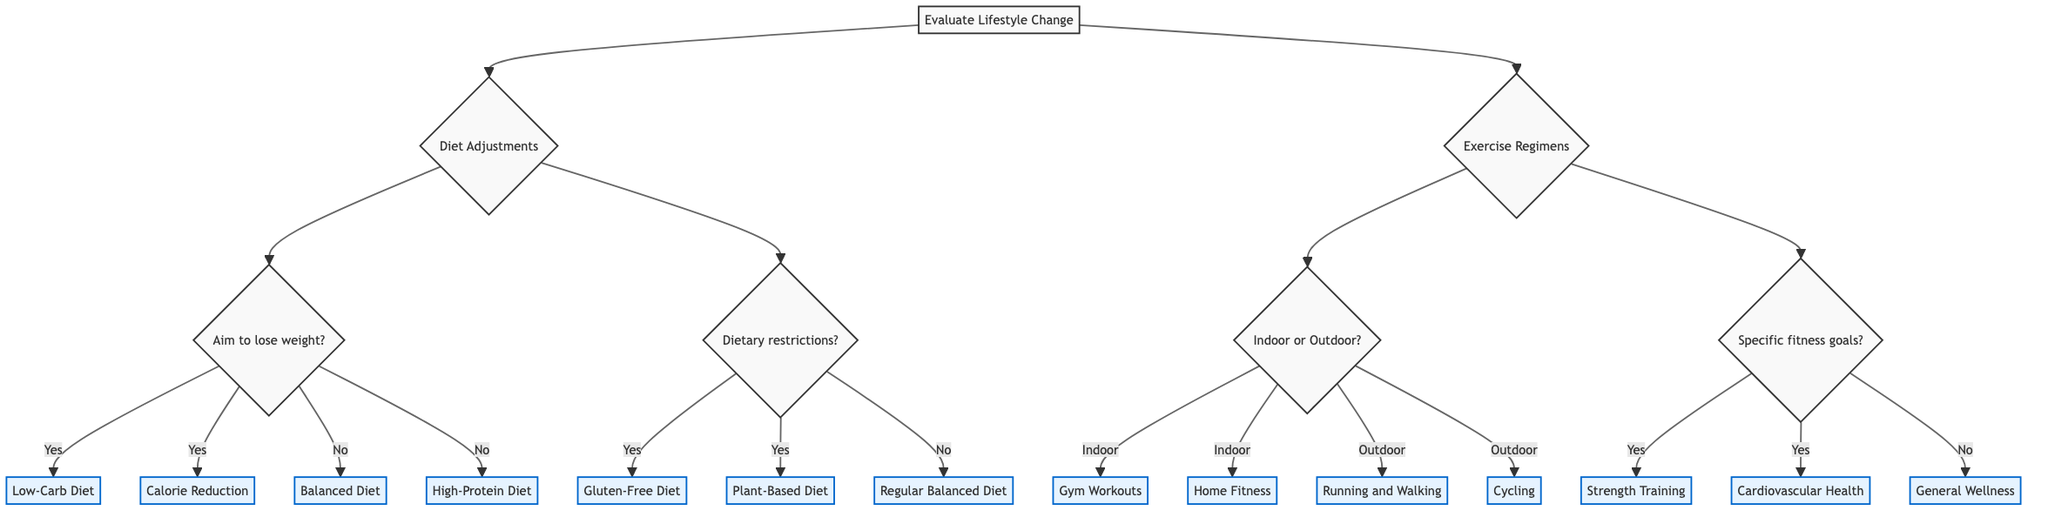What are the two main categories of lifestyle changes considered in this diagram? The diagram starts from a central point labeled "Evaluate Lifestyle Change" and branches into two main options: "Diet Adjustments" and "Exercise Regimens."
Answer: Diet Adjustments, Exercise Regimens How many options are there under "Diet Adjustments"? Under the "Diet Adjustments" branch, there are a total of four options following the questions regarding weight loss and dietary restrictions. These options include Low-Carb Diet, Calorie Reduction, Balanced Diet, and High-Protein Diet.
Answer: Four If someone wants to lose weight, what are the two diet options available to them? For someone aiming to lose weight, the diagram presents two options after they answer "yes" to the question about weight loss. These options are Low-Carb Diet and Calorie Reduction.
Answer: Low-Carb Diet, Calorie Reduction What type of exercise options can one pursue if they prefer outdoor activities? The diagram indicates that if a person selects "Outdoor" after the question about activity preference, they will be given two options: Running and Walking, and Cycling.
Answer: Running and Walking, Cycling What exercise regimen is suggested if the individual has specific fitness goals? If the individual targets specific fitness goals, the diagram shows that they can choose between Strength Training or Cardiovascular Health. These are found in the exercise assessment section focused on fitness goals.
Answer: Strength Training, Cardiovascular Health What detail is provided for those considering a Plant-Based Diet? The diagram includes a specific detail for the Plant-Based Diet option within the dietary adjustments criteria. It suggests focusing on vegetables, fruits, nuts, and seeds and mentions considering a vegan or vegetarian diet.
Answer: Focus on vegetables, fruits, nuts, and seeds. Consider a vegan or vegetarian diet If someone is not targeting specific fitness goals, what regimen is recommended? In the exercise regime section, if the individual answers "no" to the question about targeting specific fitness goals, the diagram leads them to "General Wellness," which suggests a balanced mix of activities for overall health.
Answer: General Wellness What two workout choices are available for indoor activities? According to the indoor options provided in the diagram, individuals can choose between Gym Workouts and Home Fitness. These options appear after the question about preference for indoor or outdoor activities.
Answer: Gym Workouts, Home Fitness How does the decision tree categorize dietary restrictions? After the initial question regarding dietary restrictions, the decision tree splits into options based on the answer. If "yes," it leads to Gluten-Free Diet and Plant-Based Diet, while "no" leads to a Regular Balanced Diet.
Answer: Gluten-Free Diet, Plant-Based Diet, Regular Balanced Diet 